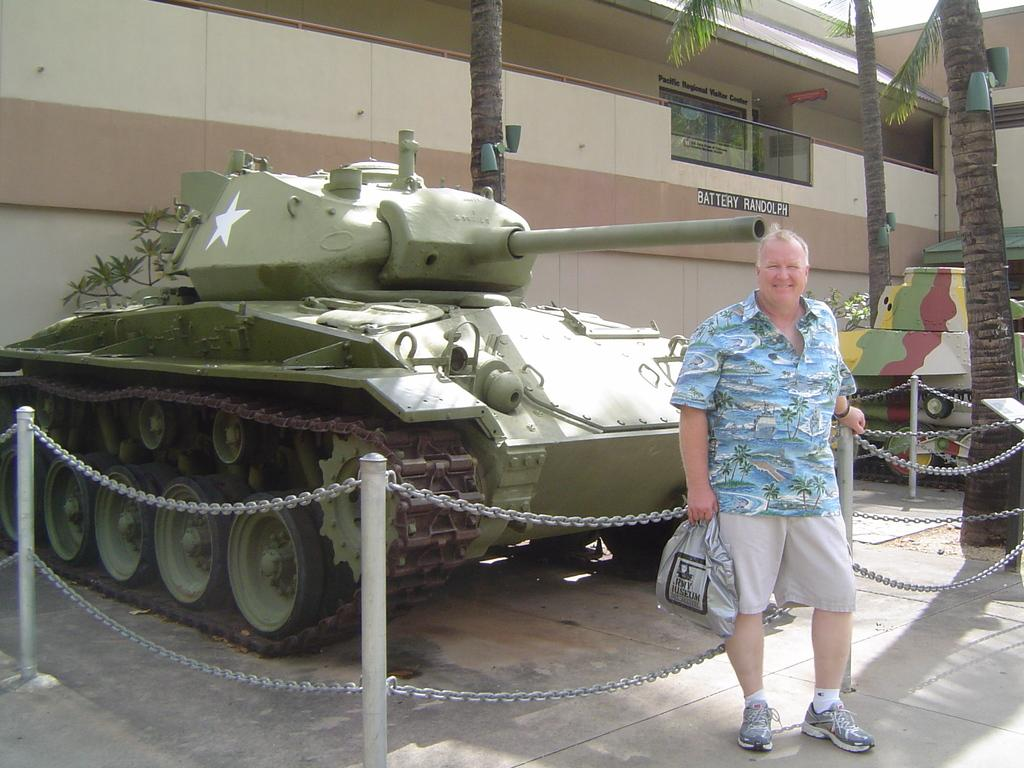What is the person in the image holding? The person in the image is holding a bag. What type of vehicles are present in the image? There are military tankers in the image. What type of barrier can be seen in the image? There is fencing in the image. What type of vegetation is present in the image? There are trees and plants in the image. What type of structures are present in the image? There are buildings in the image. What type of illumination is present in the image? There are lights in the image. What part of the natural environment is visible in the image? The sky and the ground are visible in the image. How many grapes are being carried by the person in the image? There are no grapes present in the image. What type of team is visible in the image? There is no team present in the image. 